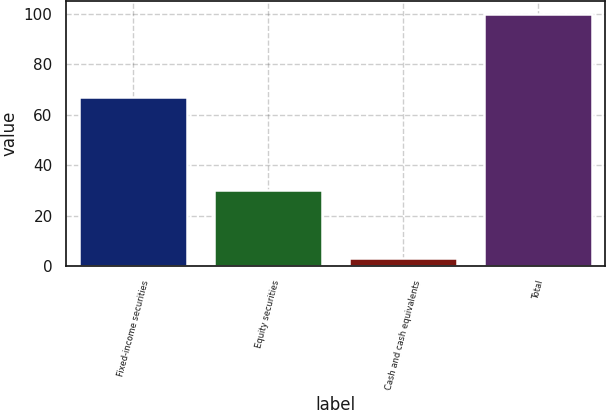<chart> <loc_0><loc_0><loc_500><loc_500><bar_chart><fcel>Fixed-income securities<fcel>Equity securities<fcel>Cash and cash equivalents<fcel>Total<nl><fcel>67<fcel>30<fcel>3<fcel>100<nl></chart> 